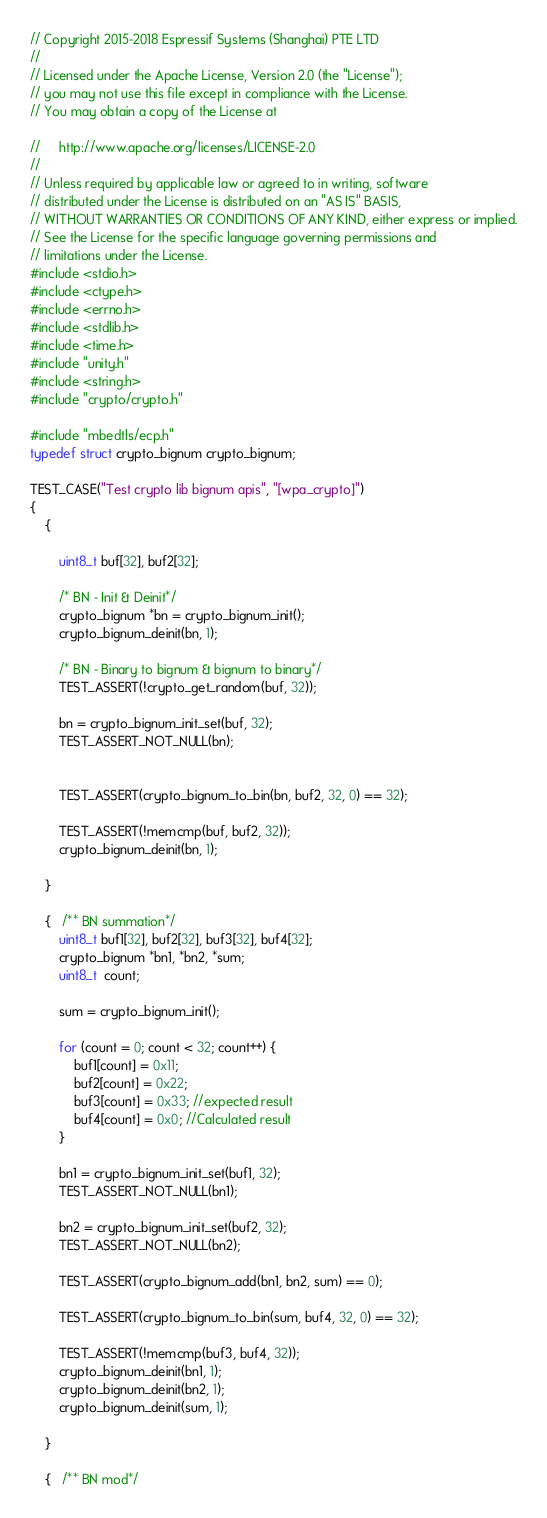<code> <loc_0><loc_0><loc_500><loc_500><_C_>// Copyright 2015-2018 Espressif Systems (Shanghai) PTE LTD
//
// Licensed under the Apache License, Version 2.0 (the "License");
// you may not use this file except in compliance with the License.
// You may obtain a copy of the License at

//     http://www.apache.org/licenses/LICENSE-2.0
//
// Unless required by applicable law or agreed to in writing, software
// distributed under the License is distributed on an "AS IS" BASIS,
// WITHOUT WARRANTIES OR CONDITIONS OF ANY KIND, either express or implied.
// See the License for the specific language governing permissions and
// limitations under the License.
#include <stdio.h>
#include <ctype.h>
#include <errno.h>
#include <stdlib.h>
#include <time.h>
#include "unity.h"
#include <string.h>
#include "crypto/crypto.h"

#include "mbedtls/ecp.h"
typedef struct crypto_bignum crypto_bignum;

TEST_CASE("Test crypto lib bignum apis", "[wpa_crypto]")
{
    {

        uint8_t buf[32], buf2[32];

        /* BN - Init & Deinit*/
        crypto_bignum *bn = crypto_bignum_init();
        crypto_bignum_deinit(bn, 1);

        /* BN - Binary to bignum & bignum to binary*/
        TEST_ASSERT(!crypto_get_random(buf, 32));

        bn = crypto_bignum_init_set(buf, 32);
        TEST_ASSERT_NOT_NULL(bn);


        TEST_ASSERT(crypto_bignum_to_bin(bn, buf2, 32, 0) == 32);

        TEST_ASSERT(!memcmp(buf, buf2, 32));
        crypto_bignum_deinit(bn, 1);

    }

    {   /** BN summation*/
        uint8_t buf1[32], buf2[32], buf3[32], buf4[32];
        crypto_bignum *bn1, *bn2, *sum;
        uint8_t  count;

        sum = crypto_bignum_init();

        for (count = 0; count < 32; count++) {
            buf1[count] = 0x11;
            buf2[count] = 0x22;
            buf3[count] = 0x33; //expected result
            buf4[count] = 0x0; //Calculated result
        }

        bn1 = crypto_bignum_init_set(buf1, 32);
        TEST_ASSERT_NOT_NULL(bn1);

        bn2 = crypto_bignum_init_set(buf2, 32);
        TEST_ASSERT_NOT_NULL(bn2);

        TEST_ASSERT(crypto_bignum_add(bn1, bn2, sum) == 0);

        TEST_ASSERT(crypto_bignum_to_bin(sum, buf4, 32, 0) == 32);

        TEST_ASSERT(!memcmp(buf3, buf4, 32));
        crypto_bignum_deinit(bn1, 1);
        crypto_bignum_deinit(bn2, 1);
        crypto_bignum_deinit(sum, 1);

    }

    {   /** BN mod*/</code> 